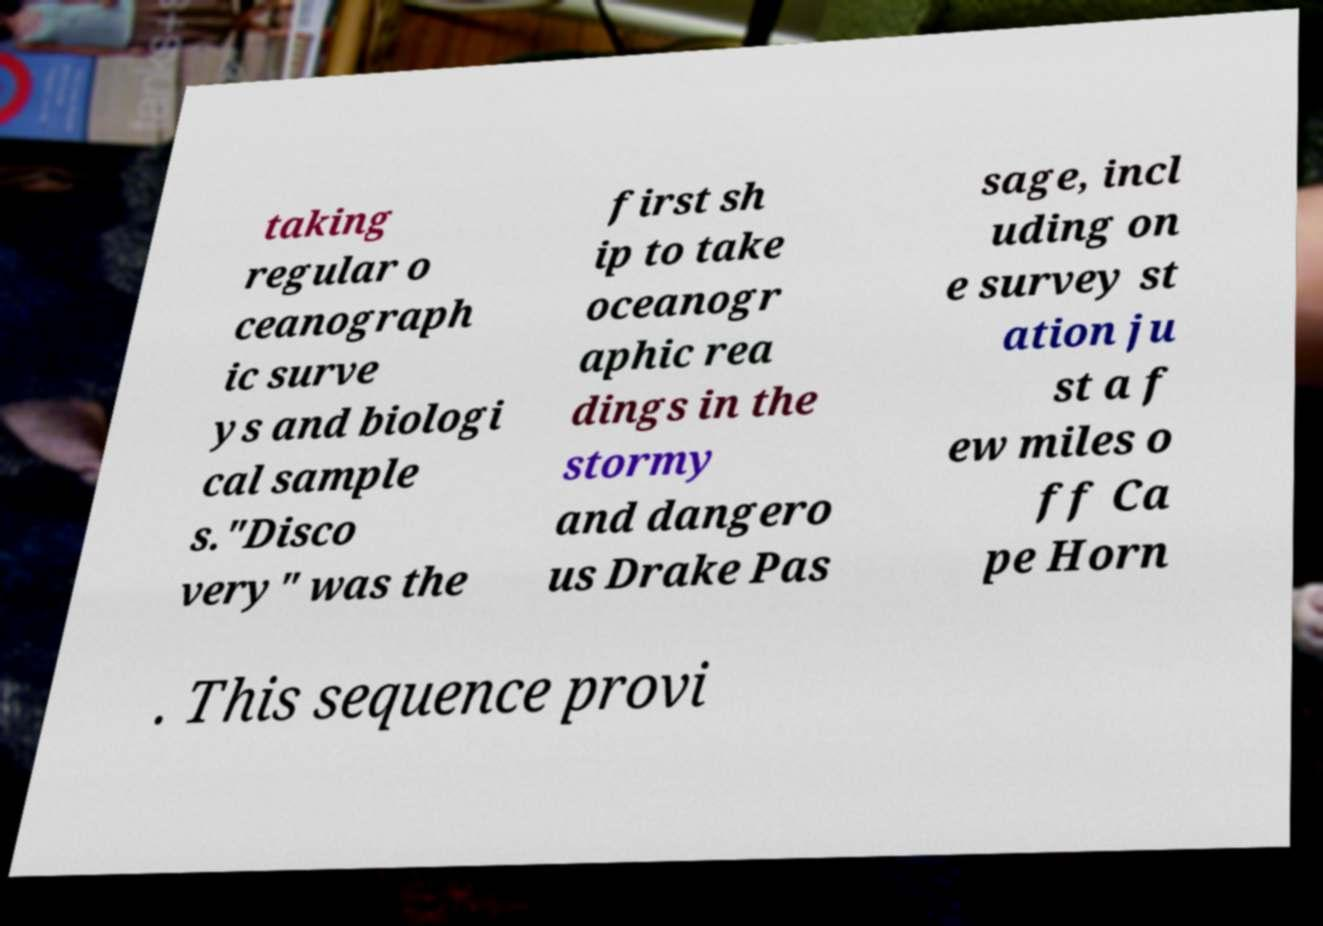Could you assist in decoding the text presented in this image and type it out clearly? taking regular o ceanograph ic surve ys and biologi cal sample s."Disco very" was the first sh ip to take oceanogr aphic rea dings in the stormy and dangero us Drake Pas sage, incl uding on e survey st ation ju st a f ew miles o ff Ca pe Horn . This sequence provi 